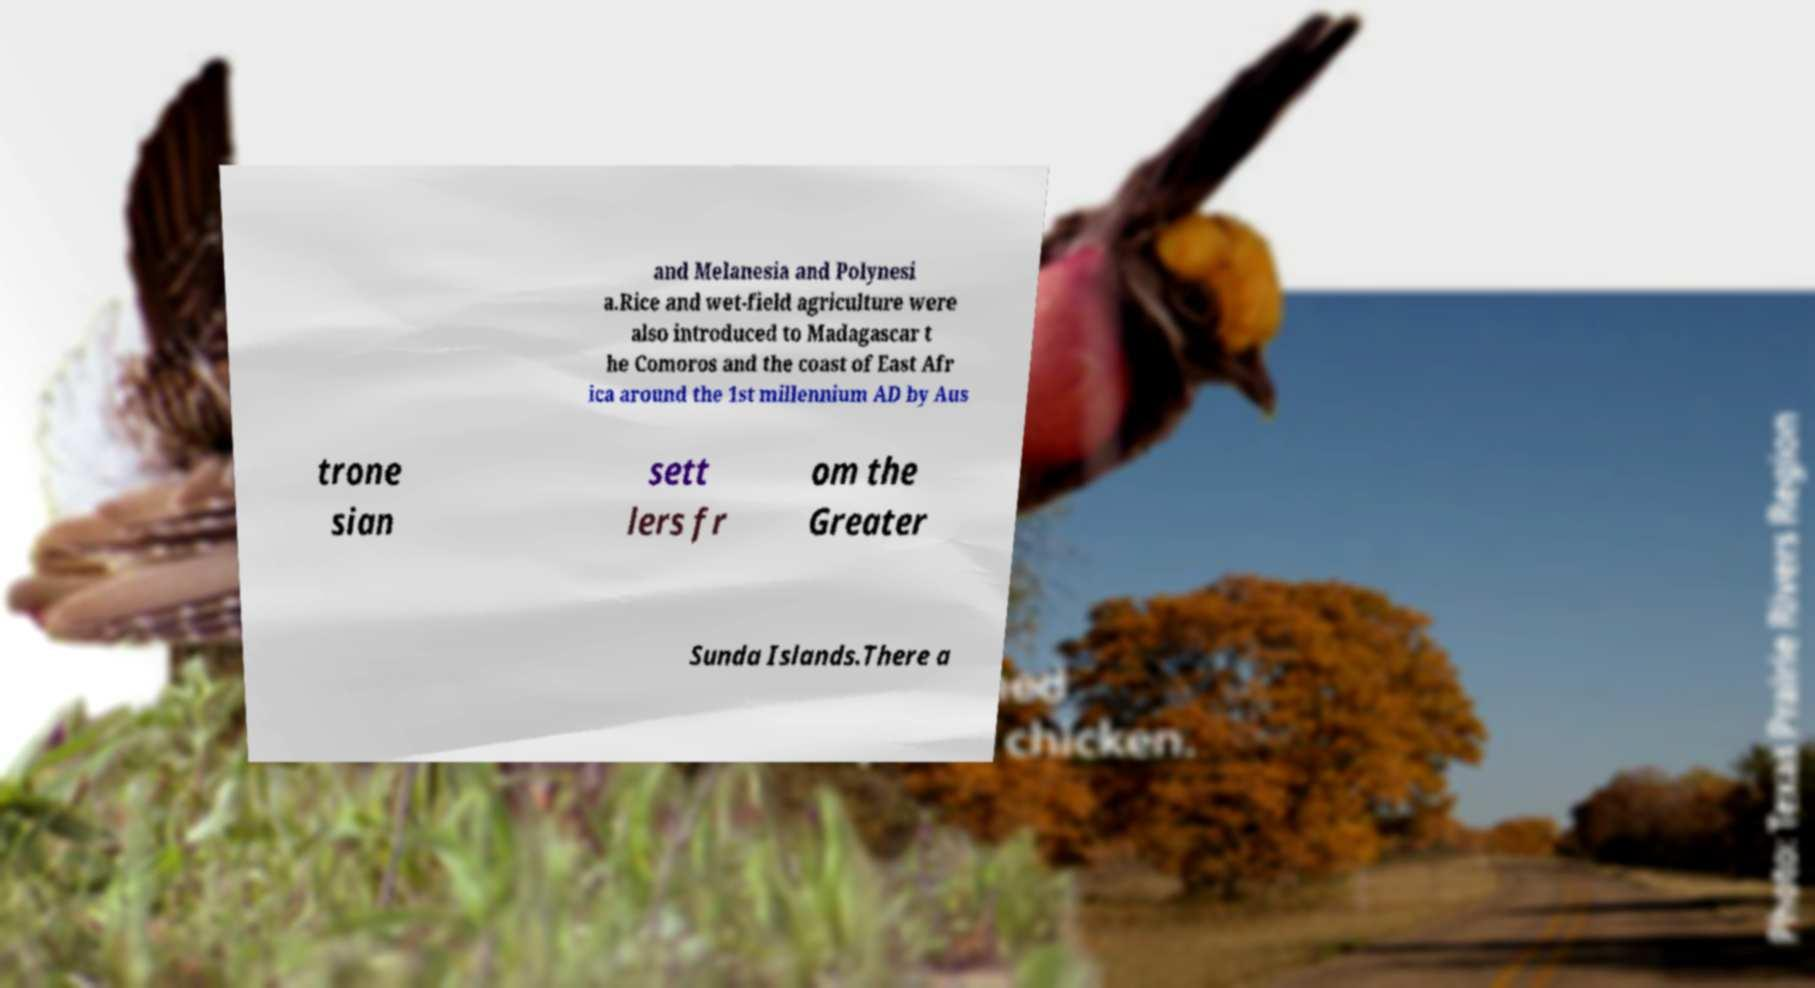Please identify and transcribe the text found in this image. and Melanesia and Polynesi a.Rice and wet-field agriculture were also introduced to Madagascar t he Comoros and the coast of East Afr ica around the 1st millennium AD by Aus trone sian sett lers fr om the Greater Sunda Islands.There a 